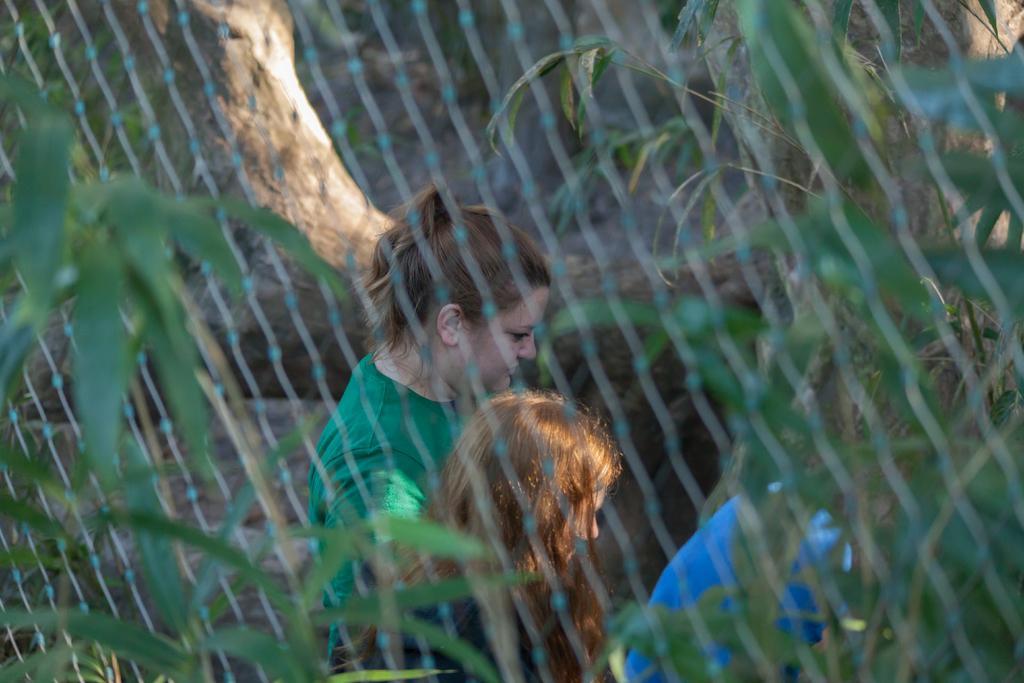In one or two sentences, can you explain what this image depicts? In this picture we can see net and some leaves in the front, there are two persons in the background. 